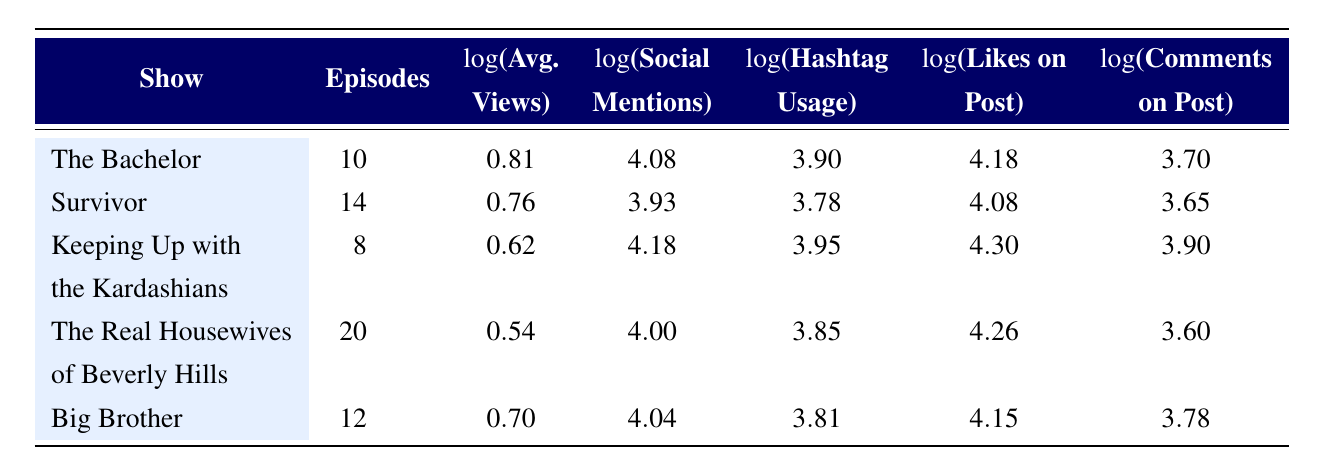What is the average number of episodes across all shows? To find the average, we total the episodes: 10 + 14 + 8 + 20 + 12 = 64 episodes. There are 5 shows, so we divide the total by the number of shows: 64 / 5 = 12.8 episodes.
Answer: 12.8 Which show has the highest logarithmic value for likes on post? Looking at the likes on post column, the maximum value is 4.30, which corresponds to "Keeping Up with the Kardashians."
Answer: Keeping Up with the Kardashians Is the number of social media mentions for "The Bachelor" higher than for "Big Brother"? The social media mentions for "The Bachelor" is 12000, while for "Big Brother" it is 11000. Since 12000 is greater than 11000, the statement is true.
Answer: Yes What is the difference in logarithmic values of average views between "The Bachelor" and "The Real Housewives of Beverly Hills"? The logarithmic value for "The Bachelor" is 0.81 and for "The Real Housewives of Beverly Hills" is 0.54. The difference is 0.81 - 0.54 = 0.27.
Answer: 0.27 Does "Survivor" have more social media mentions than "Keeping Up with the Kardashians"? "Survivor" has 8500 mentions and "Keeping Up with the Kardashians" has 15000 mentions. Since 8500 is less than 15000, the statement is false.
Answer: No What is the total number of likes on post aggregated from all shows? The total likes is calculated by summing the values: 15000 + 12000 + 20000 + 18000 + 14000 = 89000 likes.
Answer: 89000 Which show has the lowest average views logarithmic value? Examining the average views logarithmic values, the lowest is 0.54 for "The Real Housewives of Beverly Hills."
Answer: The Real Housewives of Beverly Hills Is it true that both "Big Brother" and "The Bachelor" have more than 10000 social media mentions? "Big Brother" has 11000 mentions and "The Bachelor" has 12000. Both values exceed 10000, so the statement is true.
Answer: Yes What is the average logarithmic value of hashtag usage for all shows? The total for hashtag usage is 3.90 + 3.78 + 3.95 + 3.85 + 3.81 = 19.29. Dividing by 5 gives an average of 19.29 / 5 = 3.858.
Answer: 3.858 